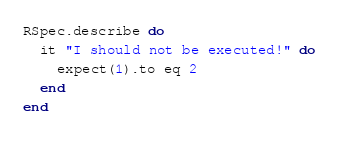Convert code to text. <code><loc_0><loc_0><loc_500><loc_500><_Ruby_>RSpec.describe do
  it "I should not be executed!" do
    expect(1).to eq 2
  end
end
</code> 